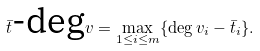<formula> <loc_0><loc_0><loc_500><loc_500>\bar { t } \text {-deg} v = \max _ { 1 \leq i \leq m } \{ \deg v _ { i } - \bar { t } _ { i } \} .</formula> 